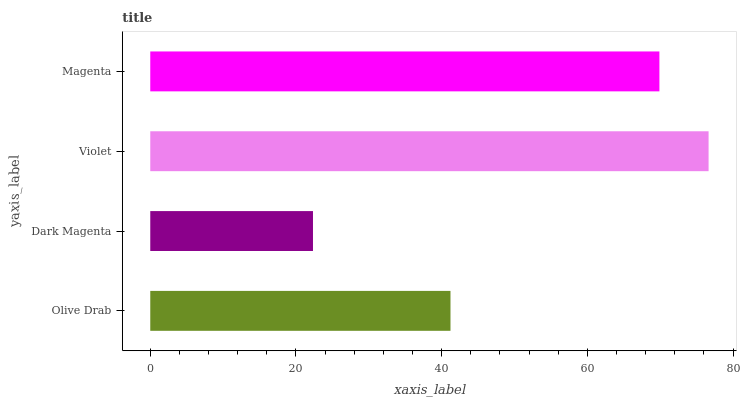Is Dark Magenta the minimum?
Answer yes or no. Yes. Is Violet the maximum?
Answer yes or no. Yes. Is Violet the minimum?
Answer yes or no. No. Is Dark Magenta the maximum?
Answer yes or no. No. Is Violet greater than Dark Magenta?
Answer yes or no. Yes. Is Dark Magenta less than Violet?
Answer yes or no. Yes. Is Dark Magenta greater than Violet?
Answer yes or no. No. Is Violet less than Dark Magenta?
Answer yes or no. No. Is Magenta the high median?
Answer yes or no. Yes. Is Olive Drab the low median?
Answer yes or no. Yes. Is Dark Magenta the high median?
Answer yes or no. No. Is Violet the low median?
Answer yes or no. No. 